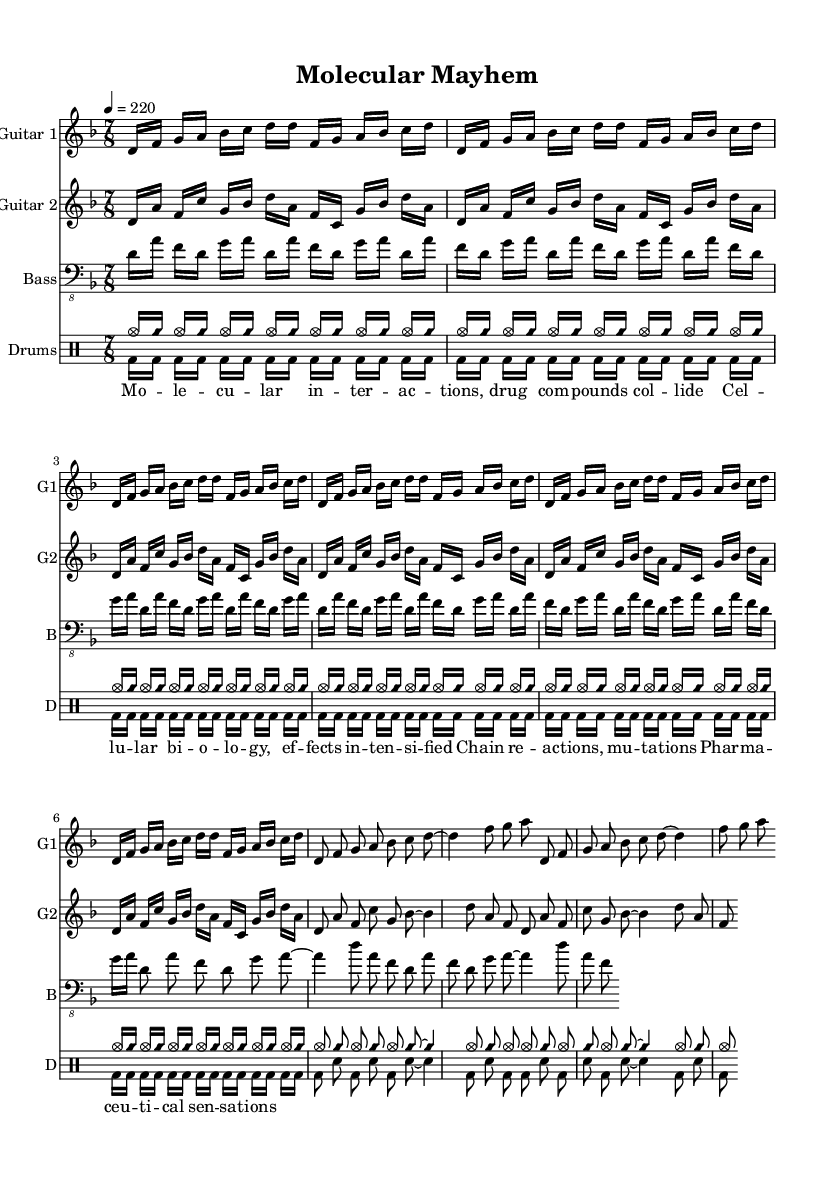What is the key signature of this music? The key signature is indicated in the global settings at the beginning of the sheet music and is set to D minor, which is shown as one flat in the key signature.
Answer: D minor What is the time signature of the piece? The time signature is stated in the global settings as 7/8, indicating a compound time signature with seven eighth notes per measure.
Answer: 7/8 What is the tempo of the music? The tempo marking specifies a speed of 220 beats per minute, as given in the global section.
Answer: 220 How many measures are in the Intro section for Guitar 1? Within the guitarOne part, the Intro section repeats twice, and each instance consists of one measure of music. Therefore, there are 2 measures in total for the Intro.
Answer: 2 What is the rhythmic notation used for the vocals? The vocal lyrics are set out with a rhythmic structure that aligns with the music; namely, it uses dashes to suggest syllable timing, revealing a basic rhythm based on quarter notes and eighth notes clearly in line with the melody.
Answer: Syllable timing What type of guitar is indicated in the sheet music? The sheet music specifies two guitars; each is clearly labeled in the staff settings. Therefore, both guitars are referred to as Guitar 1 and Guitar 2 in the score information.
Answer: Guitar 1, Guitar 2 What is the main theme described in the lyrics? The lyrics reflect a focus on molecular interactions and the biochemical processes related to drug interactions, which is a distinct theme throughout the piece, encapsulating the technical aims of the composition.
Answer: Molecular interactions 